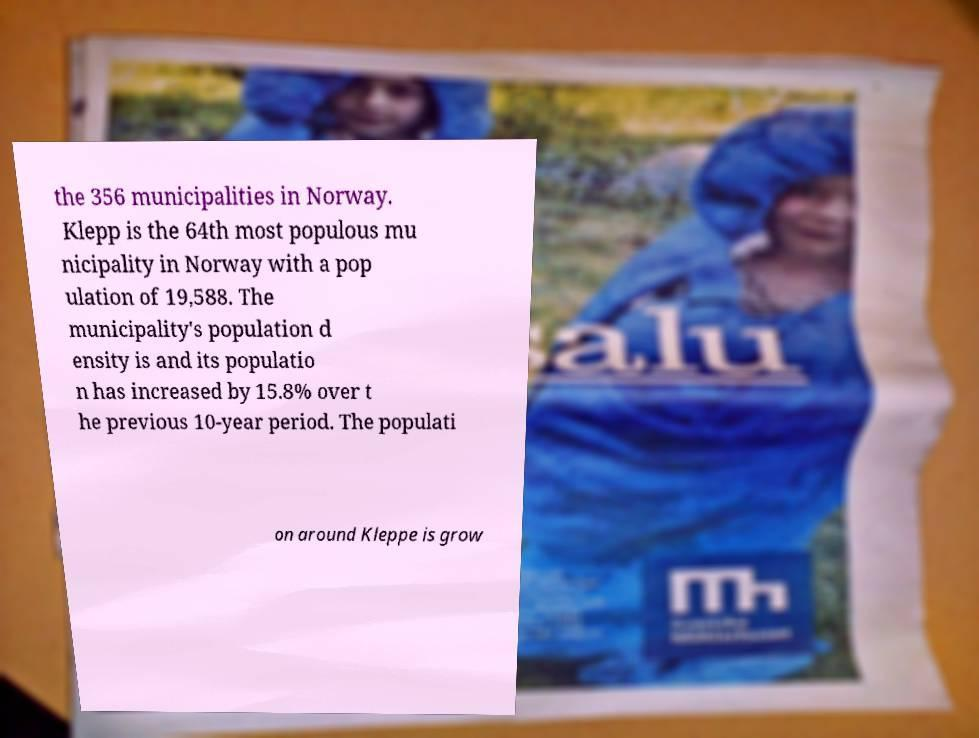Could you assist in decoding the text presented in this image and type it out clearly? the 356 municipalities in Norway. Klepp is the 64th most populous mu nicipality in Norway with a pop ulation of 19,588. The municipality's population d ensity is and its populatio n has increased by 15.8% over t he previous 10-year period. The populati on around Kleppe is grow 